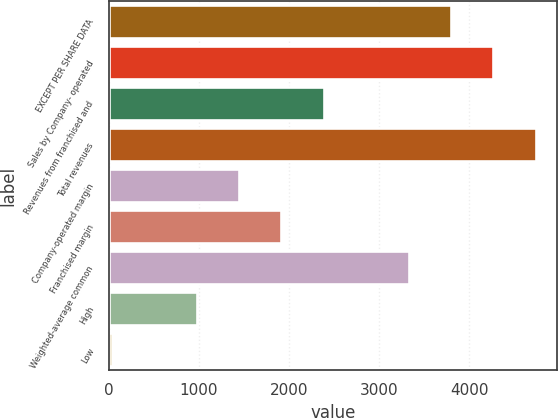Convert chart. <chart><loc_0><loc_0><loc_500><loc_500><bar_chart><fcel>EXCEPT PER SHARE DATA<fcel>Sales by Company- operated<fcel>Revenues from franchised and<fcel>Total revenues<fcel>Company-operated margin<fcel>Franchised margin<fcel>Weighted-average common<fcel>High<fcel>Low<nl><fcel>3800.48<fcel>4271.39<fcel>2387.75<fcel>4742.3<fcel>1445.93<fcel>1916.84<fcel>3329.57<fcel>975.02<fcel>33.2<nl></chart> 